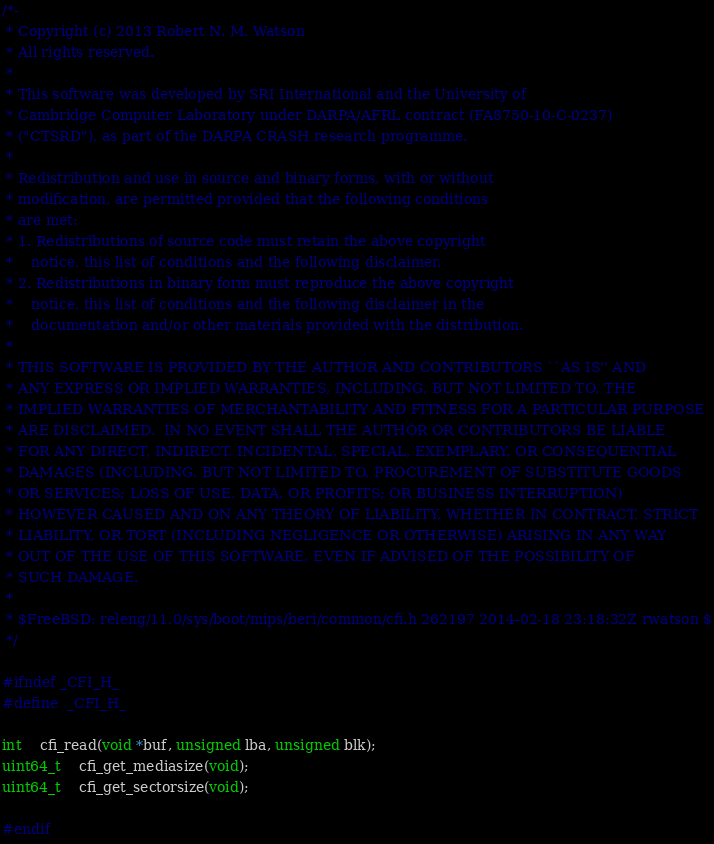<code> <loc_0><loc_0><loc_500><loc_500><_C_>/*-
 * Copyright (c) 2013 Robert N. M. Watson
 * All rights reserved.
 *
 * This software was developed by SRI International and the University of
 * Cambridge Computer Laboratory under DARPA/AFRL contract (FA8750-10-C-0237)
 * ("CTSRD"), as part of the DARPA CRASH research programme.
 *
 * Redistribution and use in source and binary forms, with or without
 * modification, are permitted provided that the following conditions
 * are met:
 * 1. Redistributions of source code must retain the above copyright
 *    notice, this list of conditions and the following disclaimer.
 * 2. Redistributions in binary form must reproduce the above copyright
 *    notice, this list of conditions and the following disclaimer in the
 *    documentation and/or other materials provided with the distribution.
 *
 * THIS SOFTWARE IS PROVIDED BY THE AUTHOR AND CONTRIBUTORS ``AS IS'' AND
 * ANY EXPRESS OR IMPLIED WARRANTIES, INCLUDING, BUT NOT LIMITED TO, THE
 * IMPLIED WARRANTIES OF MERCHANTABILITY AND FITNESS FOR A PARTICULAR PURPOSE
 * ARE DISCLAIMED.  IN NO EVENT SHALL THE AUTHOR OR CONTRIBUTORS BE LIABLE
 * FOR ANY DIRECT, INDIRECT, INCIDENTAL, SPECIAL, EXEMPLARY, OR CONSEQUENTIAL
 * DAMAGES (INCLUDING, BUT NOT LIMITED TO, PROCUREMENT OF SUBSTITUTE GOODS
 * OR SERVICES; LOSS OF USE, DATA, OR PROFITS; OR BUSINESS INTERRUPTION)
 * HOWEVER CAUSED AND ON ANY THEORY OF LIABILITY, WHETHER IN CONTRACT, STRICT
 * LIABILITY, OR TORT (INCLUDING NEGLIGENCE OR OTHERWISE) ARISING IN ANY WAY
 * OUT OF THE USE OF THIS SOFTWARE, EVEN IF ADVISED OF THE POSSIBILITY OF
 * SUCH DAMAGE.
 *
 * $FreeBSD: releng/11.0/sys/boot/mips/beri/common/cfi.h 262197 2014-02-18 23:18:32Z rwatson $
 */

#ifndef _CFI_H_
#define	_CFI_H_

int	cfi_read(void *buf, unsigned lba, unsigned blk);
uint64_t	cfi_get_mediasize(void);
uint64_t	cfi_get_sectorsize(void);

#endif
</code> 